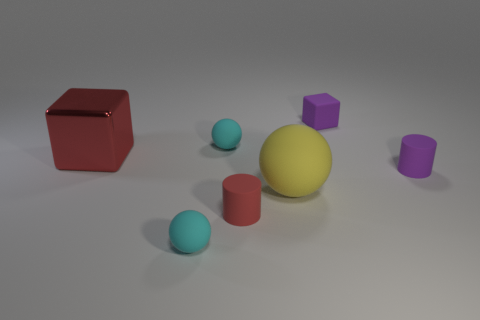Subtract all small balls. How many balls are left? 1 Subtract all brown cubes. How many cyan balls are left? 2 Subtract all yellow balls. How many balls are left? 2 Add 2 small rubber cylinders. How many objects exist? 9 Subtract 1 spheres. How many spheres are left? 2 Subtract all cubes. How many objects are left? 5 Subtract all blue balls. Subtract all cyan cylinders. How many balls are left? 3 Add 7 small gray blocks. How many small gray blocks exist? 7 Subtract 0 gray blocks. How many objects are left? 7 Subtract all big rubber spheres. Subtract all tiny red matte things. How many objects are left? 5 